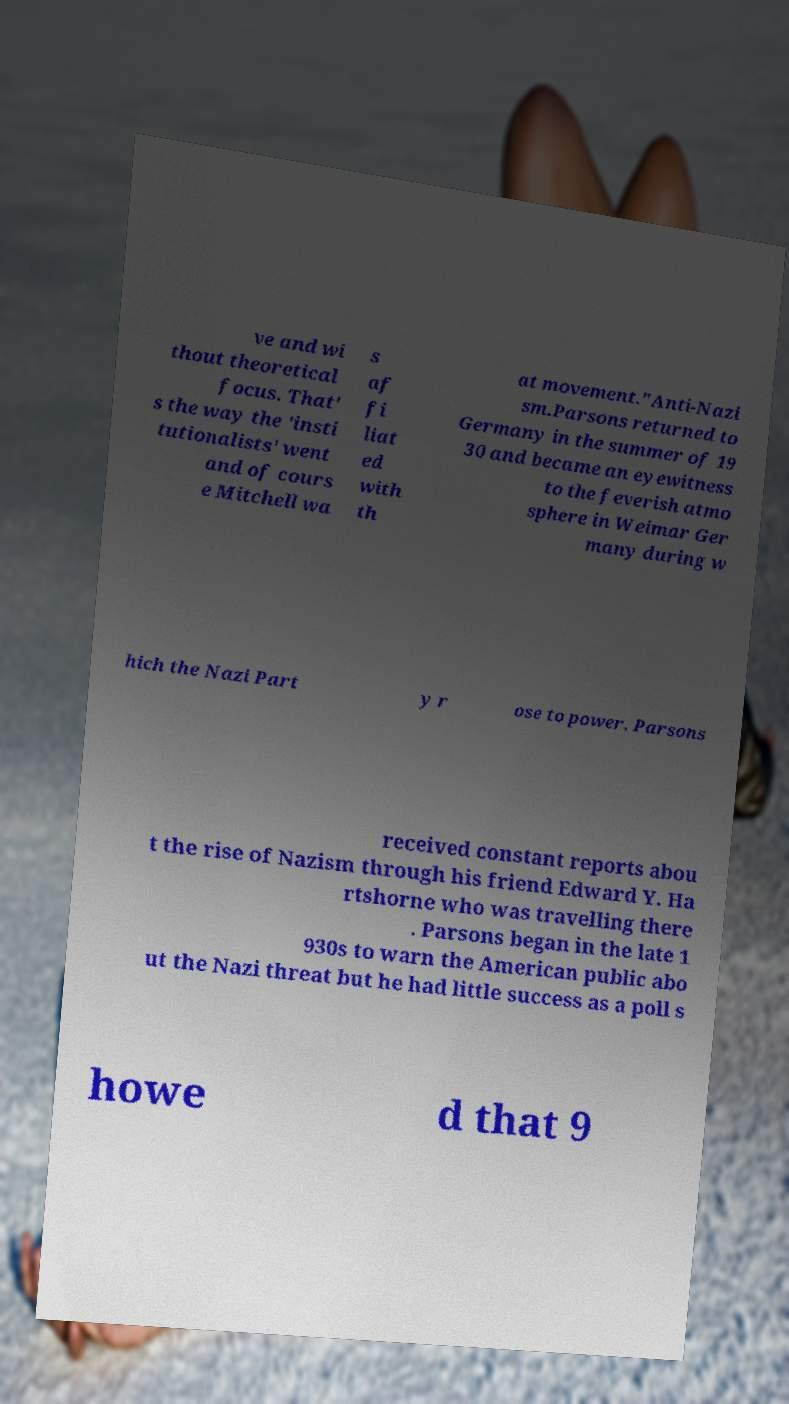Please identify and transcribe the text found in this image. ve and wi thout theoretical focus. That' s the way the 'insti tutionalists' went and of cours e Mitchell wa s af fi liat ed with th at movement."Anti-Nazi sm.Parsons returned to Germany in the summer of 19 30 and became an eyewitness to the feverish atmo sphere in Weimar Ger many during w hich the Nazi Part y r ose to power. Parsons received constant reports abou t the rise of Nazism through his friend Edward Y. Ha rtshorne who was travelling there . Parsons began in the late 1 930s to warn the American public abo ut the Nazi threat but he had little success as a poll s howe d that 9 